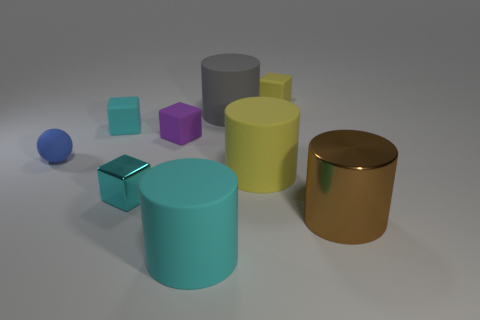There is a large yellow rubber object behind the big cyan cylinder; is it the same shape as the gray rubber thing?
Your answer should be very brief. Yes. There is a brown cylinder that is the same size as the gray cylinder; what is its material?
Your answer should be very brief. Metal. Is there a small purple cube made of the same material as the yellow cylinder?
Your answer should be very brief. Yes. There is a purple matte thing; is its shape the same as the big thing that is behind the matte sphere?
Your answer should be compact. No. What number of objects are both to the left of the big metal thing and in front of the big yellow cylinder?
Your answer should be compact. 2. Does the brown thing have the same material as the cyan object that is to the right of the cyan shiny cube?
Your answer should be compact. No. Is the number of big brown objects that are to the left of the big brown metallic cylinder the same as the number of small purple blocks?
Provide a short and direct response. No. What color is the big object on the right side of the yellow cube?
Make the answer very short. Brown. What number of other objects are the same color as the tiny metallic block?
Ensure brevity in your answer.  2. Do the matte object that is in front of the brown object and the brown shiny cylinder have the same size?
Your answer should be very brief. Yes. 